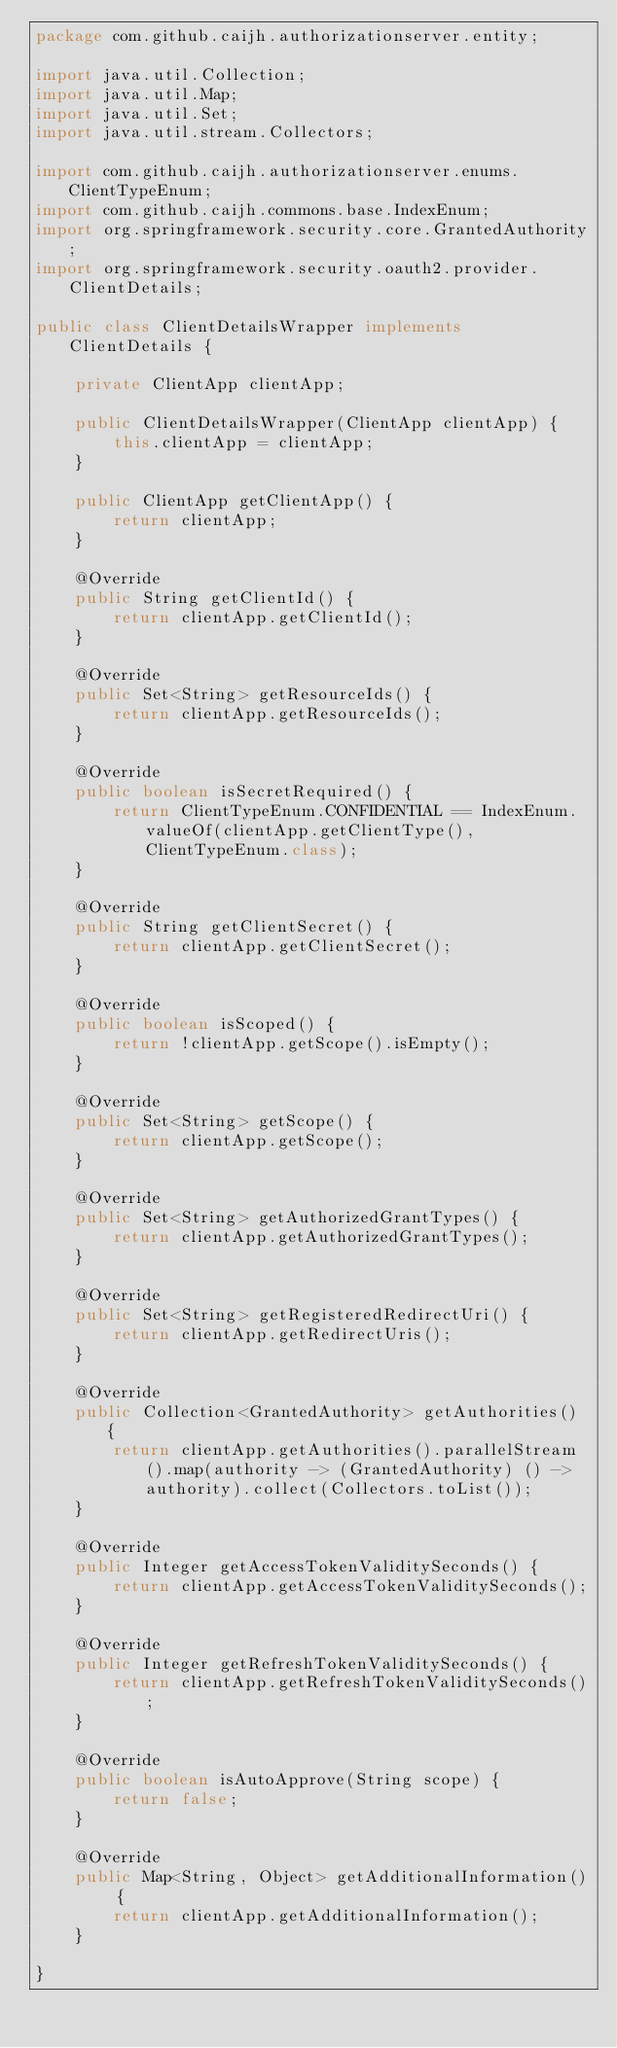<code> <loc_0><loc_0><loc_500><loc_500><_Java_>package com.github.caijh.authorizationserver.entity;

import java.util.Collection;
import java.util.Map;
import java.util.Set;
import java.util.stream.Collectors;

import com.github.caijh.authorizationserver.enums.ClientTypeEnum;
import com.github.caijh.commons.base.IndexEnum;
import org.springframework.security.core.GrantedAuthority;
import org.springframework.security.oauth2.provider.ClientDetails;

public class ClientDetailsWrapper implements ClientDetails {

    private ClientApp clientApp;

    public ClientDetailsWrapper(ClientApp clientApp) {
        this.clientApp = clientApp;
    }

    public ClientApp getClientApp() {
        return clientApp;
    }

    @Override
    public String getClientId() {
        return clientApp.getClientId();
    }

    @Override
    public Set<String> getResourceIds() {
        return clientApp.getResourceIds();
    }

    @Override
    public boolean isSecretRequired() {
        return ClientTypeEnum.CONFIDENTIAL == IndexEnum.valueOf(clientApp.getClientType(), ClientTypeEnum.class);
    }

    @Override
    public String getClientSecret() {
        return clientApp.getClientSecret();
    }

    @Override
    public boolean isScoped() {
        return !clientApp.getScope().isEmpty();
    }

    @Override
    public Set<String> getScope() {
        return clientApp.getScope();
    }

    @Override
    public Set<String> getAuthorizedGrantTypes() {
        return clientApp.getAuthorizedGrantTypes();
    }

    @Override
    public Set<String> getRegisteredRedirectUri() {
        return clientApp.getRedirectUris();
    }

    @Override
    public Collection<GrantedAuthority> getAuthorities() {
        return clientApp.getAuthorities().parallelStream().map(authority -> (GrantedAuthority) () -> authority).collect(Collectors.toList());
    }

    @Override
    public Integer getAccessTokenValiditySeconds() {
        return clientApp.getAccessTokenValiditySeconds();
    }

    @Override
    public Integer getRefreshTokenValiditySeconds() {
        return clientApp.getRefreshTokenValiditySeconds();
    }

    @Override
    public boolean isAutoApprove(String scope) {
        return false;
    }

    @Override
    public Map<String, Object> getAdditionalInformation() {
        return clientApp.getAdditionalInformation();
    }

}
</code> 